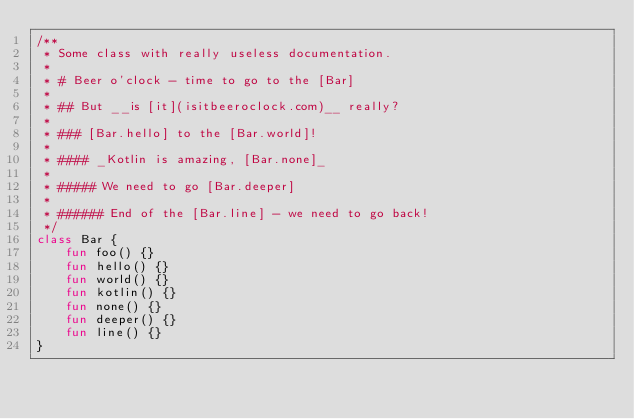<code> <loc_0><loc_0><loc_500><loc_500><_Kotlin_>/**
 * Some class with really useless documentation.
 *
 * # Beer o'clock - time to go to the [Bar]
 *
 * ## But __is [it](isitbeeroclock.com)__ really?
 *
 * ### [Bar.hello] to the [Bar.world]!
 *
 * #### _Kotlin is amazing, [Bar.none]_
 *
 * ##### We need to go [Bar.deeper]
 *
 * ###### End of the [Bar.line] - we need to go back!
 */
class Bar {
    fun foo() {}
    fun hello() {}
    fun world() {}
    fun kotlin() {}
    fun none() {}
    fun deeper() {}
    fun line() {}
}
</code> 